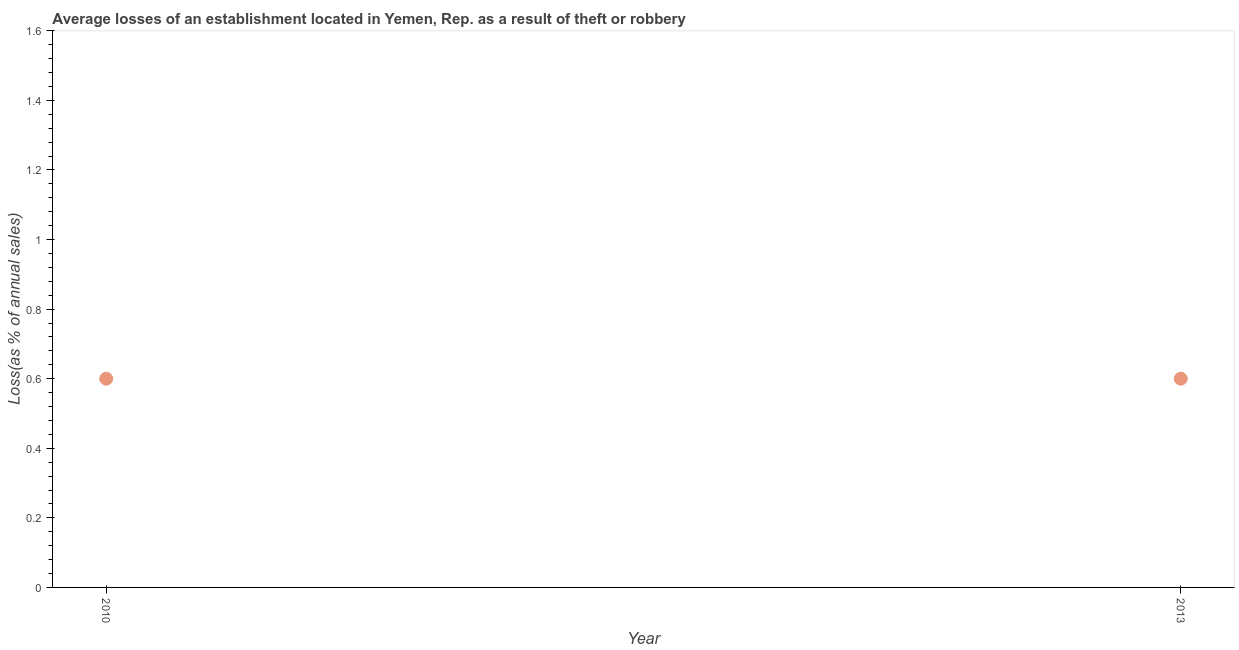What is the losses due to theft in 2013?
Make the answer very short. 0.6. Across all years, what is the maximum losses due to theft?
Offer a very short reply. 0.6. Across all years, what is the minimum losses due to theft?
Provide a short and direct response. 0.6. In which year was the losses due to theft maximum?
Your response must be concise. 2010. In which year was the losses due to theft minimum?
Offer a terse response. 2010. What is the sum of the losses due to theft?
Provide a short and direct response. 1.2. What is the average losses due to theft per year?
Offer a very short reply. 0.6. What is the median losses due to theft?
Your response must be concise. 0.6. In how many years, is the losses due to theft greater than 1.4800000000000002 %?
Your answer should be very brief. 0. Do a majority of the years between 2013 and 2010 (inclusive) have losses due to theft greater than 1.2400000000000002 %?
Your answer should be compact. No. What is the ratio of the losses due to theft in 2010 to that in 2013?
Provide a succinct answer. 1. Is the losses due to theft in 2010 less than that in 2013?
Provide a succinct answer. No. In how many years, is the losses due to theft greater than the average losses due to theft taken over all years?
Make the answer very short. 0. Does the losses due to theft monotonically increase over the years?
Your answer should be very brief. No. Are the values on the major ticks of Y-axis written in scientific E-notation?
Your response must be concise. No. Does the graph contain grids?
Provide a short and direct response. No. What is the title of the graph?
Provide a succinct answer. Average losses of an establishment located in Yemen, Rep. as a result of theft or robbery. What is the label or title of the Y-axis?
Make the answer very short. Loss(as % of annual sales). What is the Loss(as % of annual sales) in 2010?
Ensure brevity in your answer.  0.6. What is the Loss(as % of annual sales) in 2013?
Ensure brevity in your answer.  0.6. What is the ratio of the Loss(as % of annual sales) in 2010 to that in 2013?
Ensure brevity in your answer.  1. 